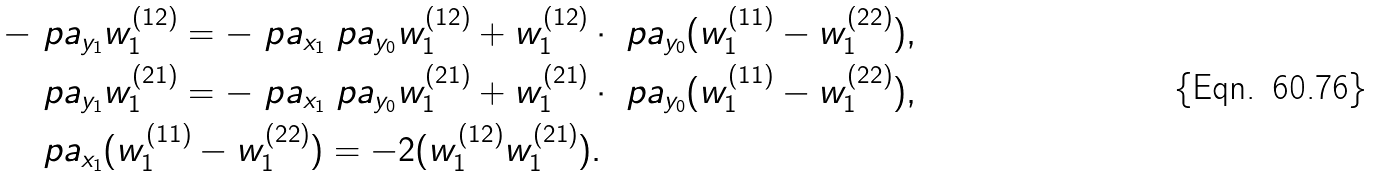Convert formula to latex. <formula><loc_0><loc_0><loc_500><loc_500>- \ p a _ { y _ { 1 } } & w _ { 1 } ^ { ( 1 2 ) } = - \ p a _ { x _ { 1 } } \ p a _ { y _ { 0 } } w _ { 1 } ^ { ( 1 2 ) } + w _ { 1 } ^ { ( 1 2 ) } \cdot \ p a _ { y _ { 0 } } ( w _ { 1 } ^ { ( 1 1 ) } - w _ { 1 } ^ { ( 2 2 ) } ) , \\ \ p a _ { y _ { 1 } } & w _ { 1 } ^ { ( 2 1 ) } = - \ p a _ { x _ { 1 } } \ p a _ { y _ { 0 } } w _ { 1 } ^ { ( 2 1 ) } + w _ { 1 } ^ { ( 2 1 ) } \cdot \ p a _ { y _ { 0 } } ( w _ { 1 } ^ { ( 1 1 ) } - w _ { 1 } ^ { ( 2 2 ) } ) , \\ \ p a _ { x _ { 1 } } & ( w _ { 1 } ^ { ( 1 1 ) } - w _ { 1 } ^ { ( 2 2 ) } ) = - 2 ( w _ { 1 } ^ { ( 1 2 ) } w _ { 1 } ^ { ( 2 1 ) } ) .</formula> 